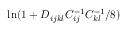<formula> <loc_0><loc_0><loc_500><loc_500>\ln ( 1 + D _ { i j k l } C _ { i j } ^ { - 1 } C _ { k l } ^ { - 1 } / 8 )</formula> 